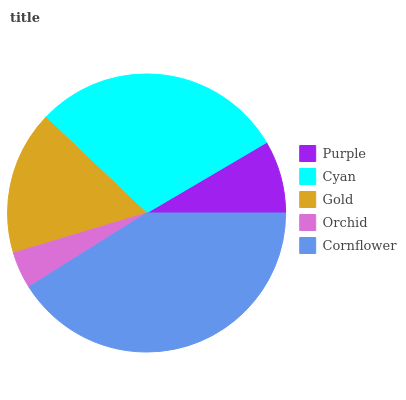Is Orchid the minimum?
Answer yes or no. Yes. Is Cornflower the maximum?
Answer yes or no. Yes. Is Cyan the minimum?
Answer yes or no. No. Is Cyan the maximum?
Answer yes or no. No. Is Cyan greater than Purple?
Answer yes or no. Yes. Is Purple less than Cyan?
Answer yes or no. Yes. Is Purple greater than Cyan?
Answer yes or no. No. Is Cyan less than Purple?
Answer yes or no. No. Is Gold the high median?
Answer yes or no. Yes. Is Gold the low median?
Answer yes or no. Yes. Is Cyan the high median?
Answer yes or no. No. Is Cornflower the low median?
Answer yes or no. No. 